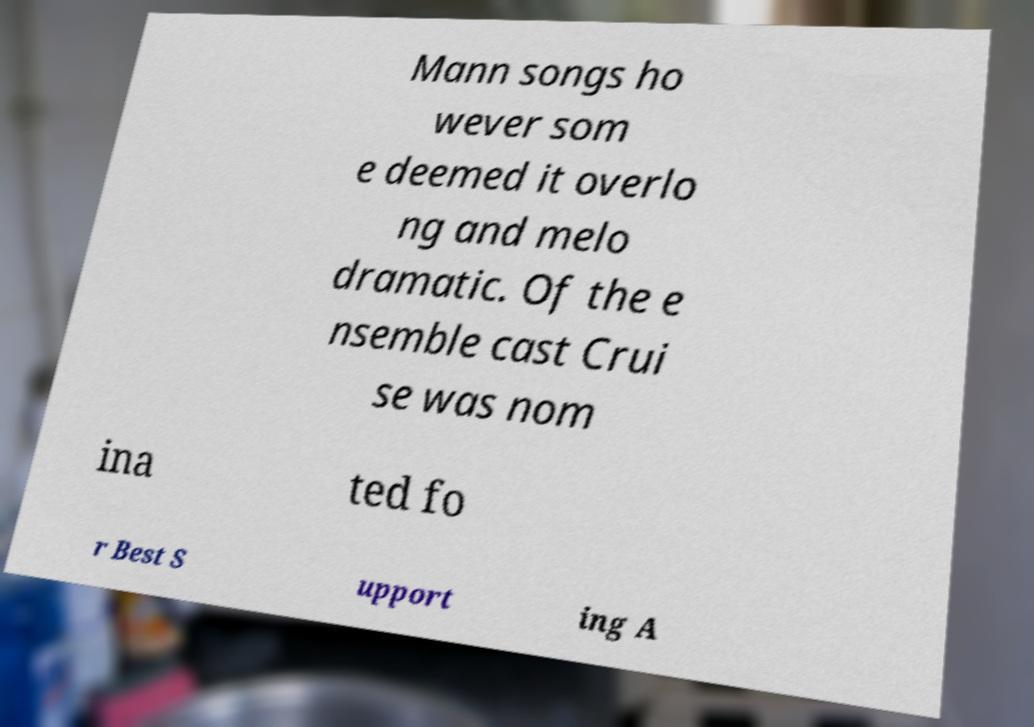Could you assist in decoding the text presented in this image and type it out clearly? Mann songs ho wever som e deemed it overlo ng and melo dramatic. Of the e nsemble cast Crui se was nom ina ted fo r Best S upport ing A 